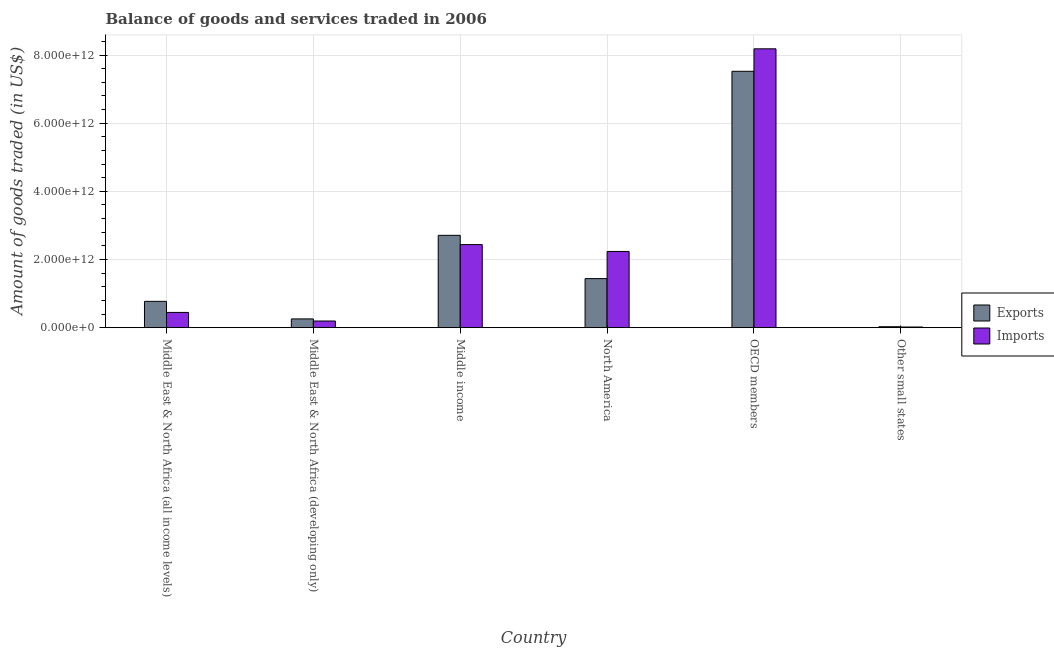What is the label of the 5th group of bars from the left?
Provide a succinct answer. OECD members. What is the amount of goods imported in Other small states?
Make the answer very short. 1.93e+1. Across all countries, what is the maximum amount of goods exported?
Give a very brief answer. 7.52e+12. Across all countries, what is the minimum amount of goods imported?
Offer a very short reply. 1.93e+1. In which country was the amount of goods imported minimum?
Provide a succinct answer. Other small states. What is the total amount of goods exported in the graph?
Your answer should be very brief. 1.27e+13. What is the difference between the amount of goods imported in North America and that in OECD members?
Your answer should be compact. -5.95e+12. What is the difference between the amount of goods exported in Middle East & North Africa (developing only) and the amount of goods imported in Middle East & North Africa (all income levels)?
Your answer should be compact. -1.90e+11. What is the average amount of goods imported per country?
Offer a terse response. 2.25e+12. What is the difference between the amount of goods exported and amount of goods imported in Other small states?
Provide a short and direct response. 8.21e+09. What is the ratio of the amount of goods imported in Middle East & North Africa (all income levels) to that in Middle income?
Provide a short and direct response. 0.18. Is the difference between the amount of goods imported in Middle income and Other small states greater than the difference between the amount of goods exported in Middle income and Other small states?
Give a very brief answer. No. What is the difference between the highest and the second highest amount of goods imported?
Provide a succinct answer. 5.74e+12. What is the difference between the highest and the lowest amount of goods exported?
Keep it short and to the point. 7.50e+12. In how many countries, is the amount of goods exported greater than the average amount of goods exported taken over all countries?
Your answer should be very brief. 2. What does the 1st bar from the left in OECD members represents?
Ensure brevity in your answer.  Exports. What does the 2nd bar from the right in Middle East & North Africa (developing only) represents?
Give a very brief answer. Exports. Are all the bars in the graph horizontal?
Your answer should be very brief. No. What is the difference between two consecutive major ticks on the Y-axis?
Make the answer very short. 2.00e+12. Are the values on the major ticks of Y-axis written in scientific E-notation?
Your answer should be very brief. Yes. Does the graph contain any zero values?
Give a very brief answer. No. How many legend labels are there?
Ensure brevity in your answer.  2. How are the legend labels stacked?
Offer a terse response. Vertical. What is the title of the graph?
Provide a succinct answer. Balance of goods and services traded in 2006. Does "Start a business" appear as one of the legend labels in the graph?
Offer a terse response. No. What is the label or title of the X-axis?
Your response must be concise. Country. What is the label or title of the Y-axis?
Offer a terse response. Amount of goods traded (in US$). What is the Amount of goods traded (in US$) in Exports in Middle East & North Africa (all income levels)?
Provide a succinct answer. 7.72e+11. What is the Amount of goods traded (in US$) of Imports in Middle East & North Africa (all income levels)?
Your answer should be very brief. 4.47e+11. What is the Amount of goods traded (in US$) in Exports in Middle East & North Africa (developing only)?
Provide a succinct answer. 2.57e+11. What is the Amount of goods traded (in US$) of Imports in Middle East & North Africa (developing only)?
Your response must be concise. 1.95e+11. What is the Amount of goods traded (in US$) in Exports in Middle income?
Offer a terse response. 2.71e+12. What is the Amount of goods traded (in US$) in Imports in Middle income?
Provide a succinct answer. 2.44e+12. What is the Amount of goods traded (in US$) in Exports in North America?
Provide a short and direct response. 1.44e+12. What is the Amount of goods traded (in US$) of Imports in North America?
Your answer should be compact. 2.24e+12. What is the Amount of goods traded (in US$) of Exports in OECD members?
Offer a terse response. 7.52e+12. What is the Amount of goods traded (in US$) of Imports in OECD members?
Keep it short and to the point. 8.18e+12. What is the Amount of goods traded (in US$) in Exports in Other small states?
Your answer should be very brief. 2.76e+1. What is the Amount of goods traded (in US$) in Imports in Other small states?
Give a very brief answer. 1.93e+1. Across all countries, what is the maximum Amount of goods traded (in US$) of Exports?
Ensure brevity in your answer.  7.52e+12. Across all countries, what is the maximum Amount of goods traded (in US$) in Imports?
Give a very brief answer. 8.18e+12. Across all countries, what is the minimum Amount of goods traded (in US$) in Exports?
Offer a very short reply. 2.76e+1. Across all countries, what is the minimum Amount of goods traded (in US$) of Imports?
Offer a terse response. 1.93e+1. What is the total Amount of goods traded (in US$) in Exports in the graph?
Your answer should be very brief. 1.27e+13. What is the total Amount of goods traded (in US$) in Imports in the graph?
Your answer should be very brief. 1.35e+13. What is the difference between the Amount of goods traded (in US$) of Exports in Middle East & North Africa (all income levels) and that in Middle East & North Africa (developing only)?
Provide a short and direct response. 5.15e+11. What is the difference between the Amount of goods traded (in US$) of Imports in Middle East & North Africa (all income levels) and that in Middle East & North Africa (developing only)?
Your response must be concise. 2.51e+11. What is the difference between the Amount of goods traded (in US$) of Exports in Middle East & North Africa (all income levels) and that in Middle income?
Your answer should be compact. -1.94e+12. What is the difference between the Amount of goods traded (in US$) of Imports in Middle East & North Africa (all income levels) and that in Middle income?
Make the answer very short. -1.99e+12. What is the difference between the Amount of goods traded (in US$) in Exports in Middle East & North Africa (all income levels) and that in North America?
Give a very brief answer. -6.67e+11. What is the difference between the Amount of goods traded (in US$) in Imports in Middle East & North Africa (all income levels) and that in North America?
Offer a terse response. -1.79e+12. What is the difference between the Amount of goods traded (in US$) of Exports in Middle East & North Africa (all income levels) and that in OECD members?
Give a very brief answer. -6.75e+12. What is the difference between the Amount of goods traded (in US$) of Imports in Middle East & North Africa (all income levels) and that in OECD members?
Your answer should be very brief. -7.74e+12. What is the difference between the Amount of goods traded (in US$) in Exports in Middle East & North Africa (all income levels) and that in Other small states?
Offer a terse response. 7.44e+11. What is the difference between the Amount of goods traded (in US$) in Imports in Middle East & North Africa (all income levels) and that in Other small states?
Offer a terse response. 4.28e+11. What is the difference between the Amount of goods traded (in US$) in Exports in Middle East & North Africa (developing only) and that in Middle income?
Offer a very short reply. -2.45e+12. What is the difference between the Amount of goods traded (in US$) of Imports in Middle East & North Africa (developing only) and that in Middle income?
Your response must be concise. -2.24e+12. What is the difference between the Amount of goods traded (in US$) of Exports in Middle East & North Africa (developing only) and that in North America?
Keep it short and to the point. -1.18e+12. What is the difference between the Amount of goods traded (in US$) in Imports in Middle East & North Africa (developing only) and that in North America?
Offer a very short reply. -2.04e+12. What is the difference between the Amount of goods traded (in US$) of Exports in Middle East & North Africa (developing only) and that in OECD members?
Keep it short and to the point. -7.27e+12. What is the difference between the Amount of goods traded (in US$) of Imports in Middle East & North Africa (developing only) and that in OECD members?
Provide a succinct answer. -7.99e+12. What is the difference between the Amount of goods traded (in US$) of Exports in Middle East & North Africa (developing only) and that in Other small states?
Ensure brevity in your answer.  2.29e+11. What is the difference between the Amount of goods traded (in US$) of Imports in Middle East & North Africa (developing only) and that in Other small states?
Provide a succinct answer. 1.76e+11. What is the difference between the Amount of goods traded (in US$) of Exports in Middle income and that in North America?
Offer a very short reply. 1.27e+12. What is the difference between the Amount of goods traded (in US$) of Imports in Middle income and that in North America?
Give a very brief answer. 2.02e+11. What is the difference between the Amount of goods traded (in US$) in Exports in Middle income and that in OECD members?
Keep it short and to the point. -4.81e+12. What is the difference between the Amount of goods traded (in US$) in Imports in Middle income and that in OECD members?
Ensure brevity in your answer.  -5.74e+12. What is the difference between the Amount of goods traded (in US$) of Exports in Middle income and that in Other small states?
Provide a succinct answer. 2.68e+12. What is the difference between the Amount of goods traded (in US$) in Imports in Middle income and that in Other small states?
Your response must be concise. 2.42e+12. What is the difference between the Amount of goods traded (in US$) in Exports in North America and that in OECD members?
Your answer should be very brief. -6.08e+12. What is the difference between the Amount of goods traded (in US$) in Imports in North America and that in OECD members?
Keep it short and to the point. -5.95e+12. What is the difference between the Amount of goods traded (in US$) in Exports in North America and that in Other small states?
Give a very brief answer. 1.41e+12. What is the difference between the Amount of goods traded (in US$) of Imports in North America and that in Other small states?
Ensure brevity in your answer.  2.22e+12. What is the difference between the Amount of goods traded (in US$) of Exports in OECD members and that in Other small states?
Your answer should be very brief. 7.50e+12. What is the difference between the Amount of goods traded (in US$) in Imports in OECD members and that in Other small states?
Ensure brevity in your answer.  8.16e+12. What is the difference between the Amount of goods traded (in US$) in Exports in Middle East & North Africa (all income levels) and the Amount of goods traded (in US$) in Imports in Middle East & North Africa (developing only)?
Your answer should be compact. 5.77e+11. What is the difference between the Amount of goods traded (in US$) in Exports in Middle East & North Africa (all income levels) and the Amount of goods traded (in US$) in Imports in Middle income?
Offer a very short reply. -1.67e+12. What is the difference between the Amount of goods traded (in US$) of Exports in Middle East & North Africa (all income levels) and the Amount of goods traded (in US$) of Imports in North America?
Offer a very short reply. -1.46e+12. What is the difference between the Amount of goods traded (in US$) in Exports in Middle East & North Africa (all income levels) and the Amount of goods traded (in US$) in Imports in OECD members?
Give a very brief answer. -7.41e+12. What is the difference between the Amount of goods traded (in US$) in Exports in Middle East & North Africa (all income levels) and the Amount of goods traded (in US$) in Imports in Other small states?
Your answer should be very brief. 7.53e+11. What is the difference between the Amount of goods traded (in US$) of Exports in Middle East & North Africa (developing only) and the Amount of goods traded (in US$) of Imports in Middle income?
Give a very brief answer. -2.18e+12. What is the difference between the Amount of goods traded (in US$) of Exports in Middle East & North Africa (developing only) and the Amount of goods traded (in US$) of Imports in North America?
Your answer should be compact. -1.98e+12. What is the difference between the Amount of goods traded (in US$) in Exports in Middle East & North Africa (developing only) and the Amount of goods traded (in US$) in Imports in OECD members?
Offer a very short reply. -7.93e+12. What is the difference between the Amount of goods traded (in US$) in Exports in Middle East & North Africa (developing only) and the Amount of goods traded (in US$) in Imports in Other small states?
Make the answer very short. 2.38e+11. What is the difference between the Amount of goods traded (in US$) in Exports in Middle income and the Amount of goods traded (in US$) in Imports in North America?
Make the answer very short. 4.73e+11. What is the difference between the Amount of goods traded (in US$) in Exports in Middle income and the Amount of goods traded (in US$) in Imports in OECD members?
Your answer should be compact. -5.47e+12. What is the difference between the Amount of goods traded (in US$) of Exports in Middle income and the Amount of goods traded (in US$) of Imports in Other small states?
Give a very brief answer. 2.69e+12. What is the difference between the Amount of goods traded (in US$) of Exports in North America and the Amount of goods traded (in US$) of Imports in OECD members?
Make the answer very short. -6.74e+12. What is the difference between the Amount of goods traded (in US$) in Exports in North America and the Amount of goods traded (in US$) in Imports in Other small states?
Keep it short and to the point. 1.42e+12. What is the difference between the Amount of goods traded (in US$) in Exports in OECD members and the Amount of goods traded (in US$) in Imports in Other small states?
Ensure brevity in your answer.  7.50e+12. What is the average Amount of goods traded (in US$) in Exports per country?
Offer a terse response. 2.12e+12. What is the average Amount of goods traded (in US$) in Imports per country?
Your answer should be compact. 2.25e+12. What is the difference between the Amount of goods traded (in US$) of Exports and Amount of goods traded (in US$) of Imports in Middle East & North Africa (all income levels)?
Offer a very short reply. 3.25e+11. What is the difference between the Amount of goods traded (in US$) in Exports and Amount of goods traded (in US$) in Imports in Middle East & North Africa (developing only)?
Provide a succinct answer. 6.15e+1. What is the difference between the Amount of goods traded (in US$) of Exports and Amount of goods traded (in US$) of Imports in Middle income?
Your response must be concise. 2.71e+11. What is the difference between the Amount of goods traded (in US$) in Exports and Amount of goods traded (in US$) in Imports in North America?
Keep it short and to the point. -7.97e+11. What is the difference between the Amount of goods traded (in US$) in Exports and Amount of goods traded (in US$) in Imports in OECD members?
Your answer should be compact. -6.59e+11. What is the difference between the Amount of goods traded (in US$) of Exports and Amount of goods traded (in US$) of Imports in Other small states?
Your answer should be very brief. 8.21e+09. What is the ratio of the Amount of goods traded (in US$) of Exports in Middle East & North Africa (all income levels) to that in Middle East & North Africa (developing only)?
Keep it short and to the point. 3. What is the ratio of the Amount of goods traded (in US$) of Imports in Middle East & North Africa (all income levels) to that in Middle East & North Africa (developing only)?
Provide a succinct answer. 2.29. What is the ratio of the Amount of goods traded (in US$) of Exports in Middle East & North Africa (all income levels) to that in Middle income?
Provide a succinct answer. 0.28. What is the ratio of the Amount of goods traded (in US$) in Imports in Middle East & North Africa (all income levels) to that in Middle income?
Ensure brevity in your answer.  0.18. What is the ratio of the Amount of goods traded (in US$) in Exports in Middle East & North Africa (all income levels) to that in North America?
Offer a very short reply. 0.54. What is the ratio of the Amount of goods traded (in US$) in Imports in Middle East & North Africa (all income levels) to that in North America?
Keep it short and to the point. 0.2. What is the ratio of the Amount of goods traded (in US$) of Exports in Middle East & North Africa (all income levels) to that in OECD members?
Provide a short and direct response. 0.1. What is the ratio of the Amount of goods traded (in US$) in Imports in Middle East & North Africa (all income levels) to that in OECD members?
Offer a very short reply. 0.05. What is the ratio of the Amount of goods traded (in US$) of Exports in Middle East & North Africa (all income levels) to that in Other small states?
Offer a very short reply. 28.02. What is the ratio of the Amount of goods traded (in US$) of Imports in Middle East & North Africa (all income levels) to that in Other small states?
Offer a terse response. 23.11. What is the ratio of the Amount of goods traded (in US$) in Exports in Middle East & North Africa (developing only) to that in Middle income?
Provide a short and direct response. 0.09. What is the ratio of the Amount of goods traded (in US$) of Imports in Middle East & North Africa (developing only) to that in Middle income?
Give a very brief answer. 0.08. What is the ratio of the Amount of goods traded (in US$) in Exports in Middle East & North Africa (developing only) to that in North America?
Provide a short and direct response. 0.18. What is the ratio of the Amount of goods traded (in US$) in Imports in Middle East & North Africa (developing only) to that in North America?
Keep it short and to the point. 0.09. What is the ratio of the Amount of goods traded (in US$) in Exports in Middle East & North Africa (developing only) to that in OECD members?
Your answer should be very brief. 0.03. What is the ratio of the Amount of goods traded (in US$) in Imports in Middle East & North Africa (developing only) to that in OECD members?
Your answer should be compact. 0.02. What is the ratio of the Amount of goods traded (in US$) of Exports in Middle East & North Africa (developing only) to that in Other small states?
Your answer should be compact. 9.33. What is the ratio of the Amount of goods traded (in US$) in Imports in Middle East & North Africa (developing only) to that in Other small states?
Your answer should be compact. 10.11. What is the ratio of the Amount of goods traded (in US$) in Exports in Middle income to that in North America?
Make the answer very short. 1.88. What is the ratio of the Amount of goods traded (in US$) in Imports in Middle income to that in North America?
Ensure brevity in your answer.  1.09. What is the ratio of the Amount of goods traded (in US$) in Exports in Middle income to that in OECD members?
Keep it short and to the point. 0.36. What is the ratio of the Amount of goods traded (in US$) in Imports in Middle income to that in OECD members?
Offer a terse response. 0.3. What is the ratio of the Amount of goods traded (in US$) in Exports in Middle income to that in Other small states?
Give a very brief answer. 98.33. What is the ratio of the Amount of goods traded (in US$) in Imports in Middle income to that in Other small states?
Your answer should be compact. 126.07. What is the ratio of the Amount of goods traded (in US$) of Exports in North America to that in OECD members?
Give a very brief answer. 0.19. What is the ratio of the Amount of goods traded (in US$) of Imports in North America to that in OECD members?
Offer a very short reply. 0.27. What is the ratio of the Amount of goods traded (in US$) in Exports in North America to that in Other small states?
Make the answer very short. 52.24. What is the ratio of the Amount of goods traded (in US$) of Imports in North America to that in Other small states?
Keep it short and to the point. 115.61. What is the ratio of the Amount of goods traded (in US$) of Exports in OECD members to that in Other small states?
Keep it short and to the point. 273.06. What is the ratio of the Amount of goods traded (in US$) of Imports in OECD members to that in Other small states?
Keep it short and to the point. 423.11. What is the difference between the highest and the second highest Amount of goods traded (in US$) in Exports?
Your answer should be very brief. 4.81e+12. What is the difference between the highest and the second highest Amount of goods traded (in US$) of Imports?
Provide a succinct answer. 5.74e+12. What is the difference between the highest and the lowest Amount of goods traded (in US$) of Exports?
Your answer should be very brief. 7.50e+12. What is the difference between the highest and the lowest Amount of goods traded (in US$) in Imports?
Keep it short and to the point. 8.16e+12. 